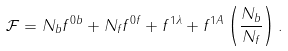Convert formula to latex. <formula><loc_0><loc_0><loc_500><loc_500>\mathcal { F } = N _ { b } f ^ { 0 b } + N _ { f } f ^ { 0 f } + f ^ { 1 \lambda } + f ^ { 1 A } \left ( \frac { N _ { b } } { N _ { f } } \right ) .</formula> 